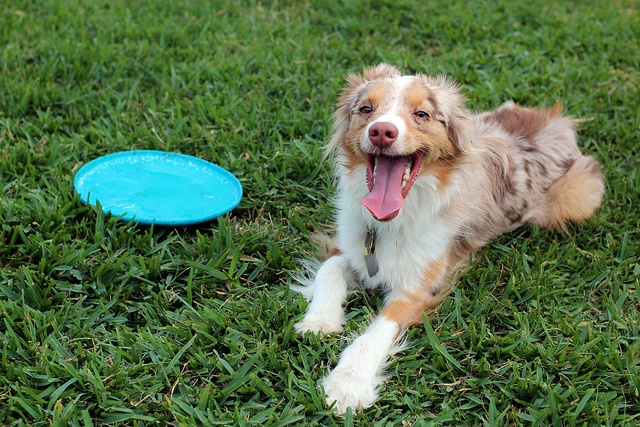Describe the objects in this image and their specific colors. I can see dog in darkgreen, darkgray, lightgray, tan, and gray tones and frisbee in darkgreen, lightblue, and black tones in this image. 